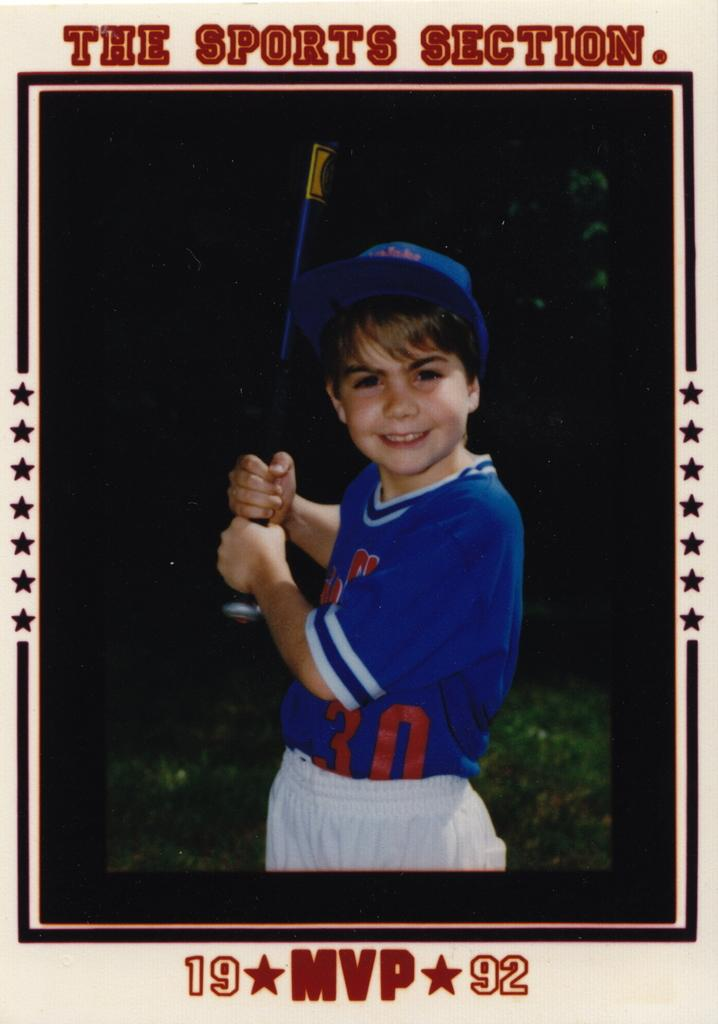<image>
Summarize the visual content of the image. A picture of a small boy holding a baseball bat under the words The Sports Section. 